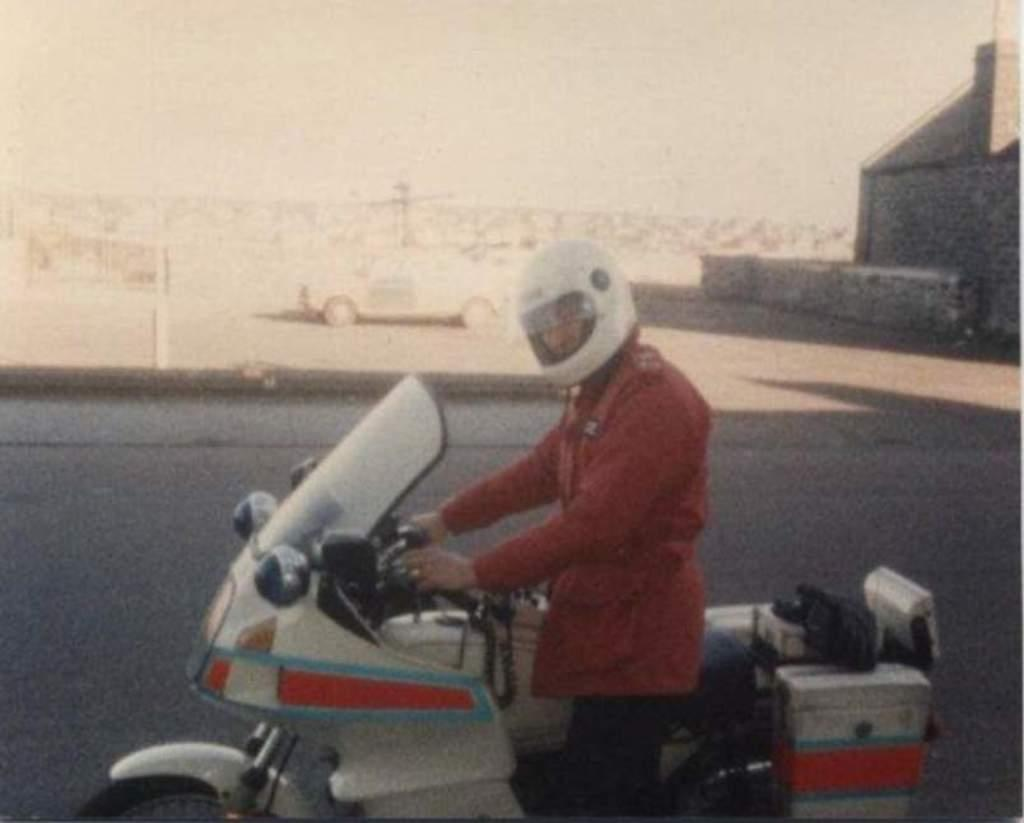What is the main subject of the image? There is a person in the image. What is the person wearing on their upper body? The person is wearing a red jacket. What type of headgear is the person wearing? The person is wearing a helmet. What color are the person's pants? The person is wearing black pants. What is the person doing in the image? The person is riding a motorbike. What can be seen in the background of the image? There is a road, a car, a building, and the sky visible in the background of the image. Can you see the person laughing while holding a crayon in the image? There is no indication of the person laughing or holding a crayon in the image. 